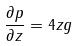<formula> <loc_0><loc_0><loc_500><loc_500>\frac { \partial p } { \partial z } = 4 z g</formula> 